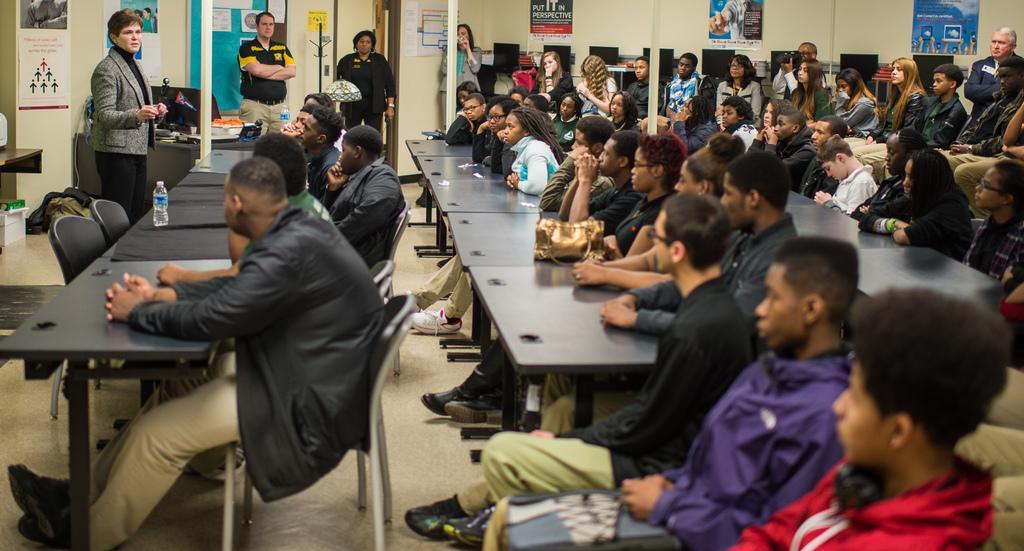Describe this image in one or two sentences. In the image we can see there are people sitting on the chairs and there is water bottle and bag kept on the table. There are posters on the wall and there are people standing in the room. 